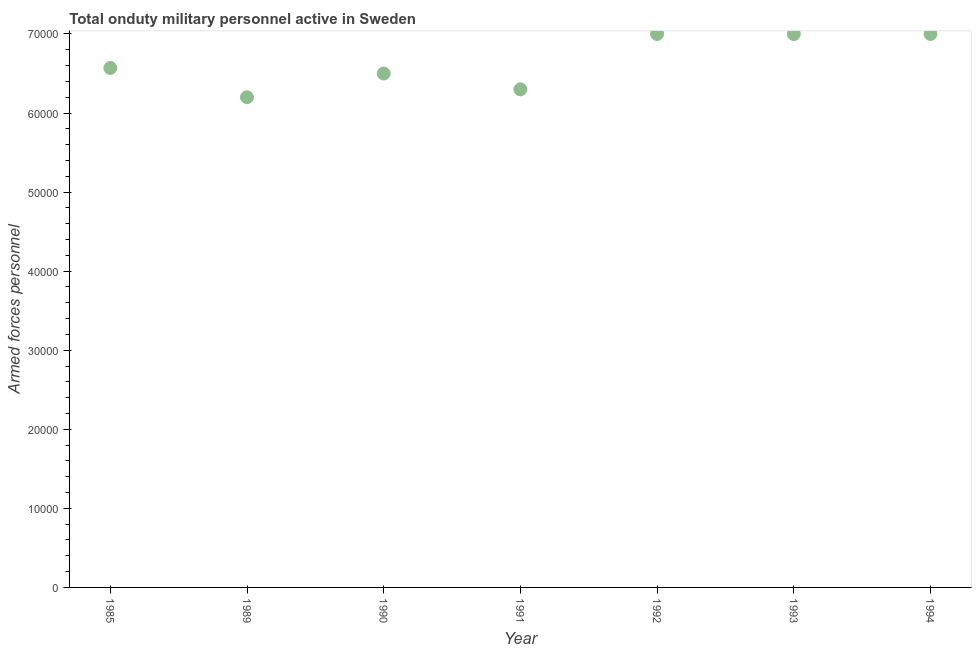What is the number of armed forces personnel in 1989?
Give a very brief answer. 6.20e+04. Across all years, what is the maximum number of armed forces personnel?
Provide a succinct answer. 7.00e+04. Across all years, what is the minimum number of armed forces personnel?
Ensure brevity in your answer.  6.20e+04. In which year was the number of armed forces personnel minimum?
Make the answer very short. 1989. What is the sum of the number of armed forces personnel?
Provide a short and direct response. 4.66e+05. What is the difference between the number of armed forces personnel in 1990 and 1992?
Provide a short and direct response. -5000. What is the average number of armed forces personnel per year?
Your response must be concise. 6.65e+04. What is the median number of armed forces personnel?
Ensure brevity in your answer.  6.57e+04. In how many years, is the number of armed forces personnel greater than 58000 ?
Your answer should be compact. 7. What is the ratio of the number of armed forces personnel in 1990 to that in 1991?
Your answer should be very brief. 1.03. What is the difference between the highest and the second highest number of armed forces personnel?
Provide a succinct answer. 0. What is the difference between the highest and the lowest number of armed forces personnel?
Keep it short and to the point. 8000. Does the number of armed forces personnel monotonically increase over the years?
Offer a very short reply. No. How many dotlines are there?
Give a very brief answer. 1. How many years are there in the graph?
Give a very brief answer. 7. What is the difference between two consecutive major ticks on the Y-axis?
Give a very brief answer. 10000. Are the values on the major ticks of Y-axis written in scientific E-notation?
Offer a very short reply. No. Does the graph contain any zero values?
Ensure brevity in your answer.  No. Does the graph contain grids?
Your answer should be very brief. No. What is the title of the graph?
Offer a very short reply. Total onduty military personnel active in Sweden. What is the label or title of the Y-axis?
Give a very brief answer. Armed forces personnel. What is the Armed forces personnel in 1985?
Offer a terse response. 6.57e+04. What is the Armed forces personnel in 1989?
Your response must be concise. 6.20e+04. What is the Armed forces personnel in 1990?
Provide a short and direct response. 6.50e+04. What is the Armed forces personnel in 1991?
Your response must be concise. 6.30e+04. What is the Armed forces personnel in 1993?
Provide a short and direct response. 7.00e+04. What is the Armed forces personnel in 1994?
Your answer should be compact. 7.00e+04. What is the difference between the Armed forces personnel in 1985 and 1989?
Offer a terse response. 3700. What is the difference between the Armed forces personnel in 1985 and 1990?
Give a very brief answer. 700. What is the difference between the Armed forces personnel in 1985 and 1991?
Your answer should be very brief. 2700. What is the difference between the Armed forces personnel in 1985 and 1992?
Provide a short and direct response. -4300. What is the difference between the Armed forces personnel in 1985 and 1993?
Your response must be concise. -4300. What is the difference between the Armed forces personnel in 1985 and 1994?
Your response must be concise. -4300. What is the difference between the Armed forces personnel in 1989 and 1990?
Provide a short and direct response. -3000. What is the difference between the Armed forces personnel in 1989 and 1991?
Your response must be concise. -1000. What is the difference between the Armed forces personnel in 1989 and 1992?
Give a very brief answer. -8000. What is the difference between the Armed forces personnel in 1989 and 1993?
Keep it short and to the point. -8000. What is the difference between the Armed forces personnel in 1989 and 1994?
Make the answer very short. -8000. What is the difference between the Armed forces personnel in 1990 and 1992?
Keep it short and to the point. -5000. What is the difference between the Armed forces personnel in 1990 and 1993?
Your answer should be compact. -5000. What is the difference between the Armed forces personnel in 1990 and 1994?
Offer a very short reply. -5000. What is the difference between the Armed forces personnel in 1991 and 1992?
Make the answer very short. -7000. What is the difference between the Armed forces personnel in 1991 and 1993?
Offer a terse response. -7000. What is the difference between the Armed forces personnel in 1991 and 1994?
Offer a very short reply. -7000. What is the difference between the Armed forces personnel in 1992 and 1993?
Make the answer very short. 0. What is the difference between the Armed forces personnel in 1993 and 1994?
Provide a short and direct response. 0. What is the ratio of the Armed forces personnel in 1985 to that in 1989?
Your answer should be compact. 1.06. What is the ratio of the Armed forces personnel in 1985 to that in 1990?
Provide a short and direct response. 1.01. What is the ratio of the Armed forces personnel in 1985 to that in 1991?
Offer a very short reply. 1.04. What is the ratio of the Armed forces personnel in 1985 to that in 1992?
Provide a short and direct response. 0.94. What is the ratio of the Armed forces personnel in 1985 to that in 1993?
Offer a very short reply. 0.94. What is the ratio of the Armed forces personnel in 1985 to that in 1994?
Provide a short and direct response. 0.94. What is the ratio of the Armed forces personnel in 1989 to that in 1990?
Ensure brevity in your answer.  0.95. What is the ratio of the Armed forces personnel in 1989 to that in 1991?
Offer a very short reply. 0.98. What is the ratio of the Armed forces personnel in 1989 to that in 1992?
Your response must be concise. 0.89. What is the ratio of the Armed forces personnel in 1989 to that in 1993?
Provide a succinct answer. 0.89. What is the ratio of the Armed forces personnel in 1989 to that in 1994?
Give a very brief answer. 0.89. What is the ratio of the Armed forces personnel in 1990 to that in 1991?
Make the answer very short. 1.03. What is the ratio of the Armed forces personnel in 1990 to that in 1992?
Offer a terse response. 0.93. What is the ratio of the Armed forces personnel in 1990 to that in 1993?
Offer a very short reply. 0.93. What is the ratio of the Armed forces personnel in 1990 to that in 1994?
Offer a very short reply. 0.93. What is the ratio of the Armed forces personnel in 1991 to that in 1993?
Keep it short and to the point. 0.9. What is the ratio of the Armed forces personnel in 1991 to that in 1994?
Offer a terse response. 0.9. What is the ratio of the Armed forces personnel in 1992 to that in 1993?
Provide a succinct answer. 1. What is the ratio of the Armed forces personnel in 1992 to that in 1994?
Offer a very short reply. 1. 